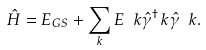Convert formula to latex. <formula><loc_0><loc_0><loc_500><loc_500>\hat { H } = E _ { G S } + \sum _ { k } E _ { \ } k \hat { \gamma } ^ { \dagger } _ { \ } k \hat { \gamma } _ { \ } k .</formula> 